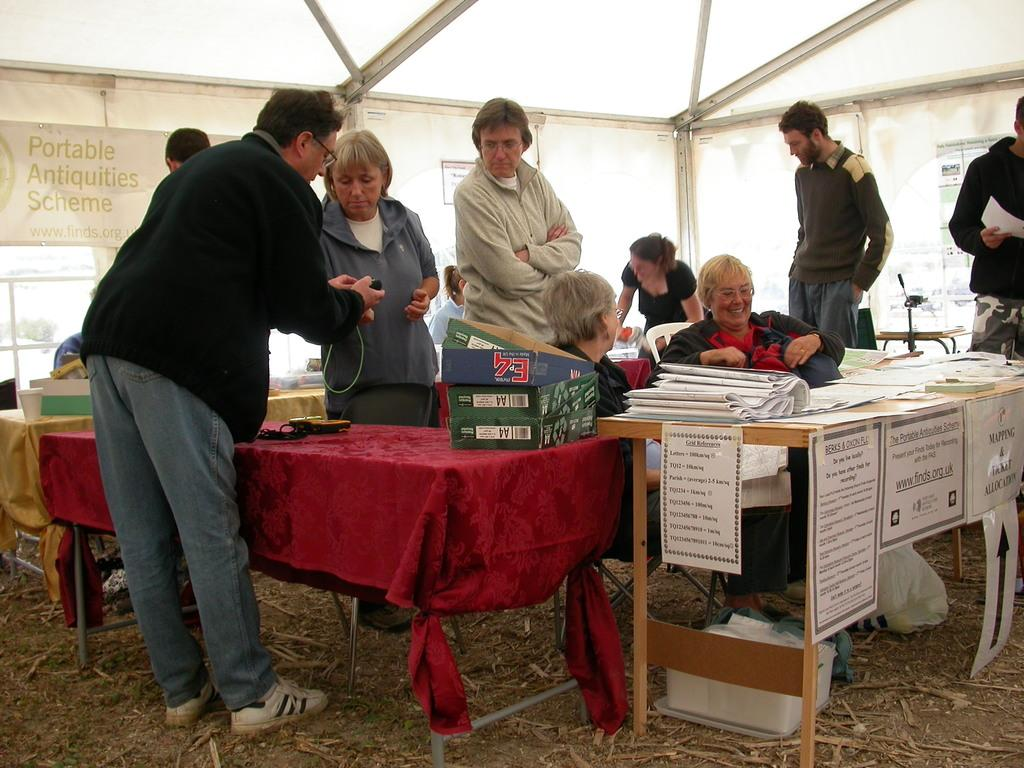How many people are in the image? There are persons in the image, but the exact number is not specified. What are the people in the image doing? Some of the persons are sitting, while others are standing. What objects can be seen on a table in the background? There are cardboard boxes on a table in the background. What is hanging in the background? There is a banner in the background. What type of structure is visible in the background? There is a tent in the background. What type of ticket is required to enter the religious event depicted in the image? There is no mention of a religious event or a ticket in the image. The image only shows persons, some sitting and others standing, with a tent, banner, and cardboard boxes in the background. 